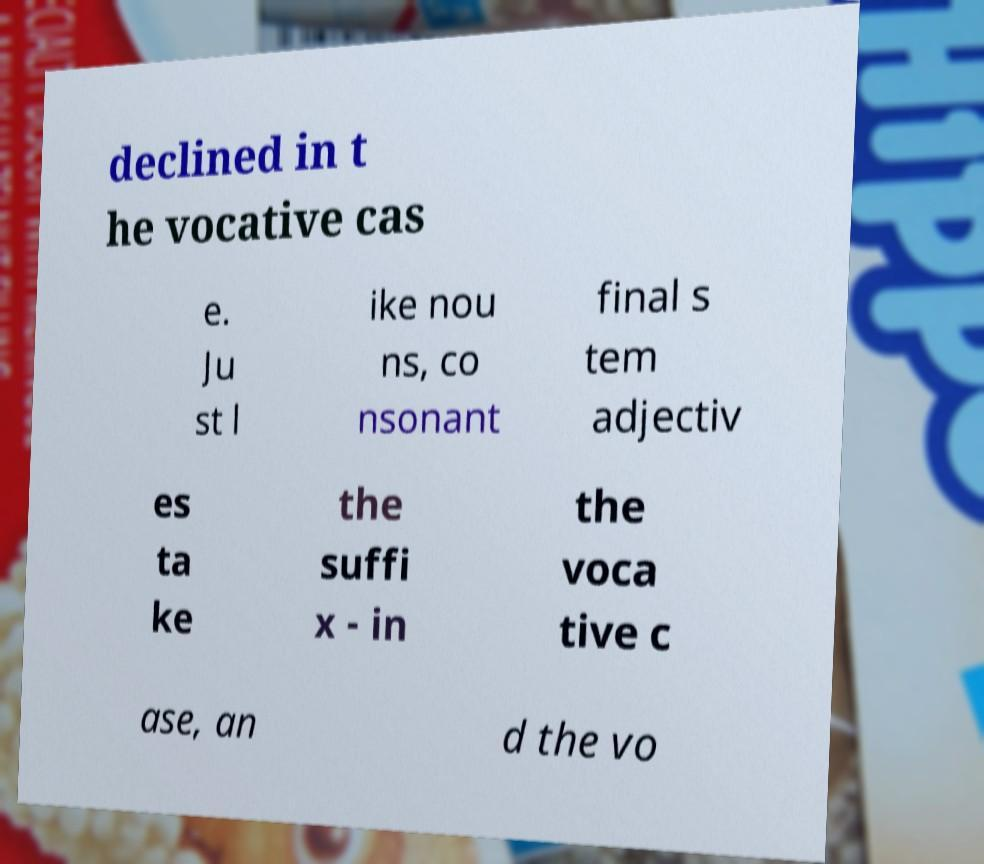What messages or text are displayed in this image? I need them in a readable, typed format. declined in t he vocative cas e. Ju st l ike nou ns, co nsonant final s tem adjectiv es ta ke the suffi x - in the voca tive c ase, an d the vo 